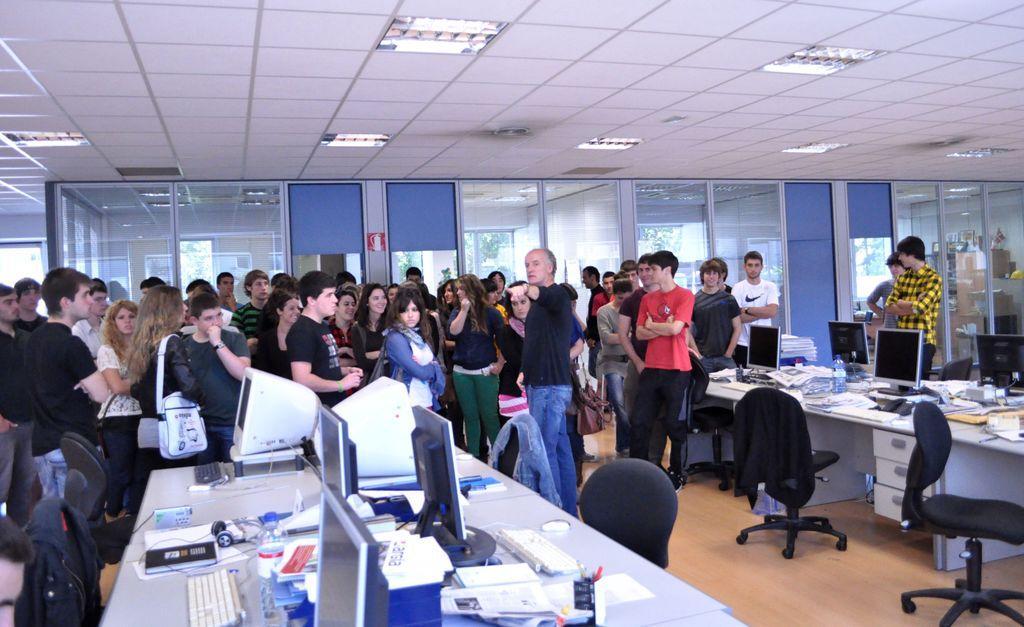Can you describe this image briefly? In this image there are many people standing. In the the middle there is a man he wears black t shirt and trouser. On the right there is a man he wears checked shirt and trouser. In the middle there are many tables, chairs, systems, computers, keyboard, mouse and bottle. In the background there is window, light and glass 